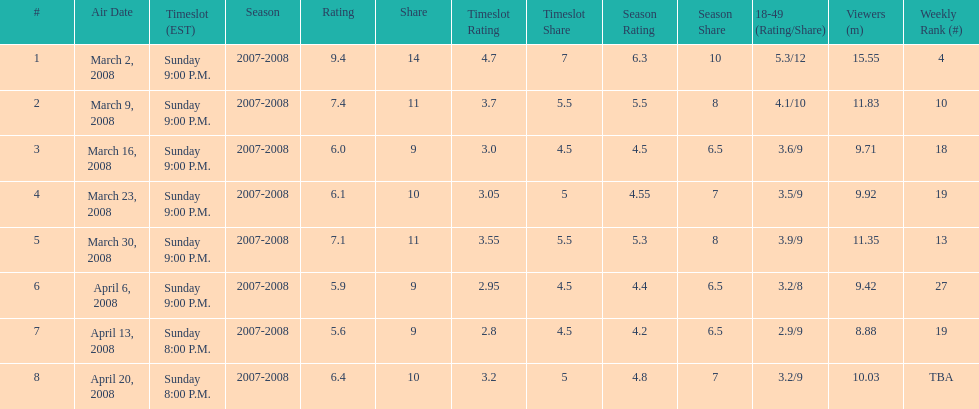Which show had the highest rating? 1. 